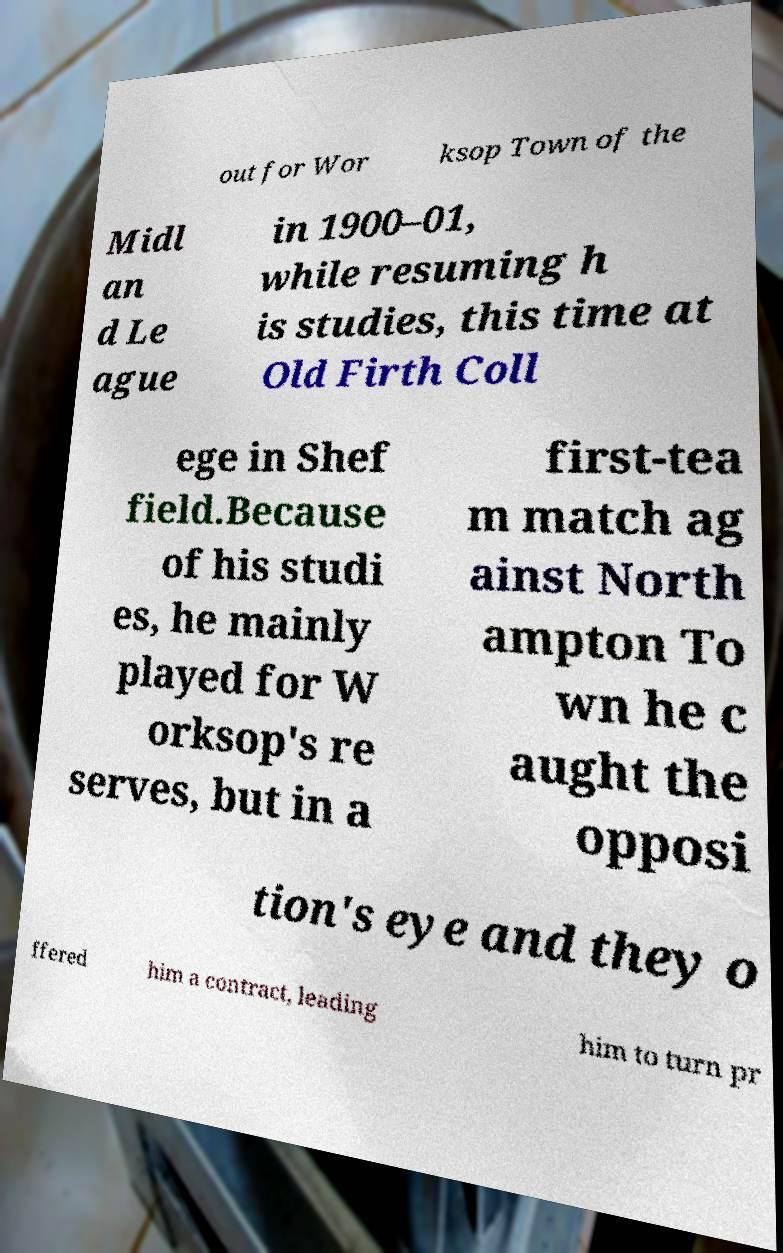What messages or text are displayed in this image? I need them in a readable, typed format. out for Wor ksop Town of the Midl an d Le ague in 1900–01, while resuming h is studies, this time at Old Firth Coll ege in Shef field.Because of his studi es, he mainly played for W orksop's re serves, but in a first-tea m match ag ainst North ampton To wn he c aught the opposi tion's eye and they o ffered him a contract, leading him to turn pr 